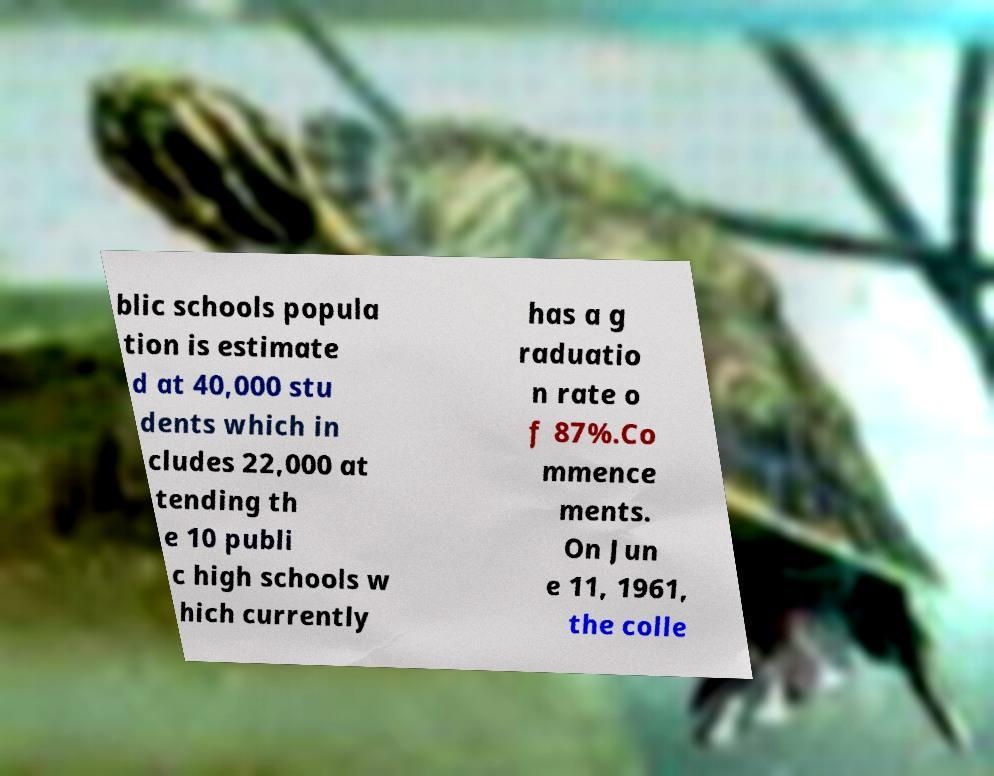Please identify and transcribe the text found in this image. blic schools popula tion is estimate d at 40,000 stu dents which in cludes 22,000 at tending th e 10 publi c high schools w hich currently has a g raduatio n rate o f 87%.Co mmence ments. On Jun e 11, 1961, the colle 